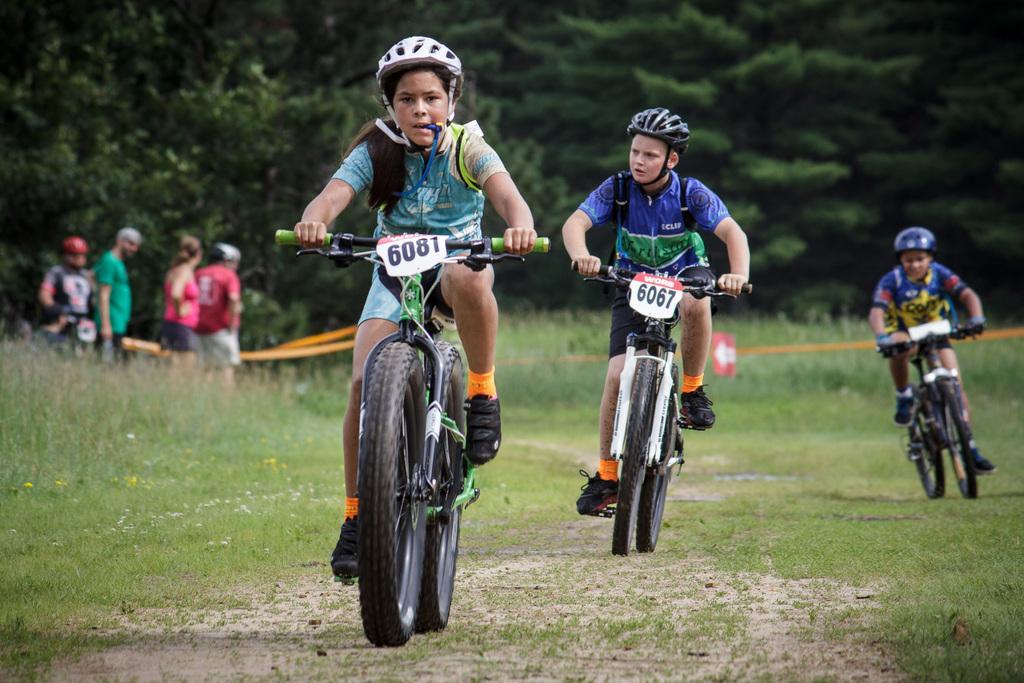Please provide a concise description of this image. In this image, we can see children riding bicycles. At the bottom of the image, we can see the grass. In the backboard, there are plants, trees, ropes and people. 